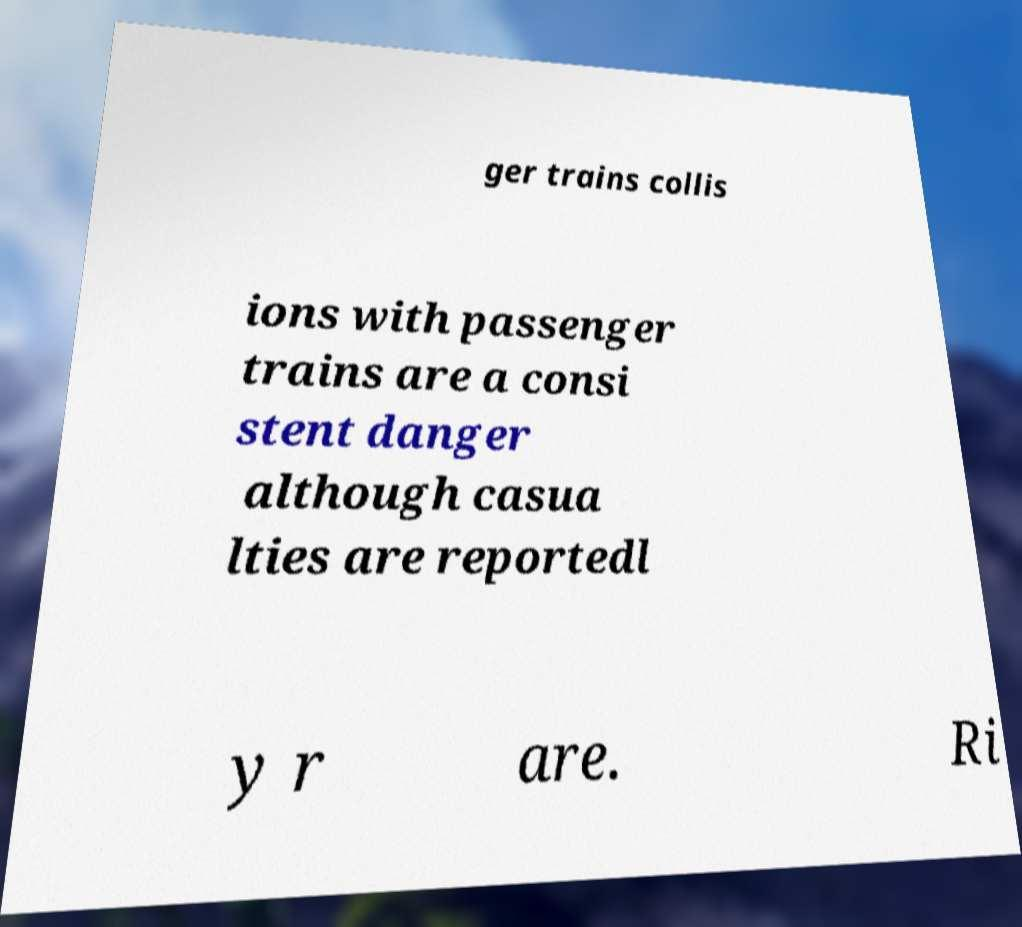I need the written content from this picture converted into text. Can you do that? ger trains collis ions with passenger trains are a consi stent danger although casua lties are reportedl y r are. Ri 